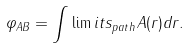Convert formula to latex. <formula><loc_0><loc_0><loc_500><loc_500>\varphi _ { A B } = \int \lim i t s _ { p a t h } { A } ( { r } ) d { r } .</formula> 